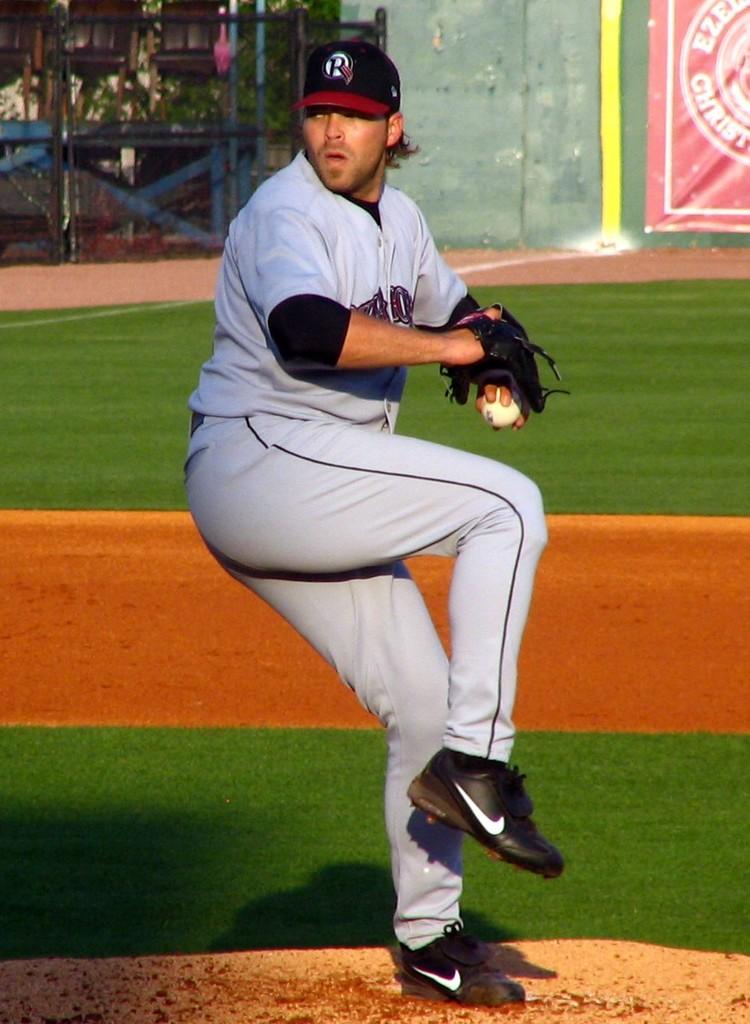What word is visible on the red banner in the background?
Make the answer very short. Christ. 